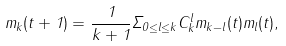Convert formula to latex. <formula><loc_0><loc_0><loc_500><loc_500>m _ { k } ( t + 1 ) = \frac { 1 } { k + 1 } \Sigma _ { 0 \leq l \leq k } C _ { k } ^ { l } m _ { k - l } ( t ) m _ { l } ( t ) ,</formula> 